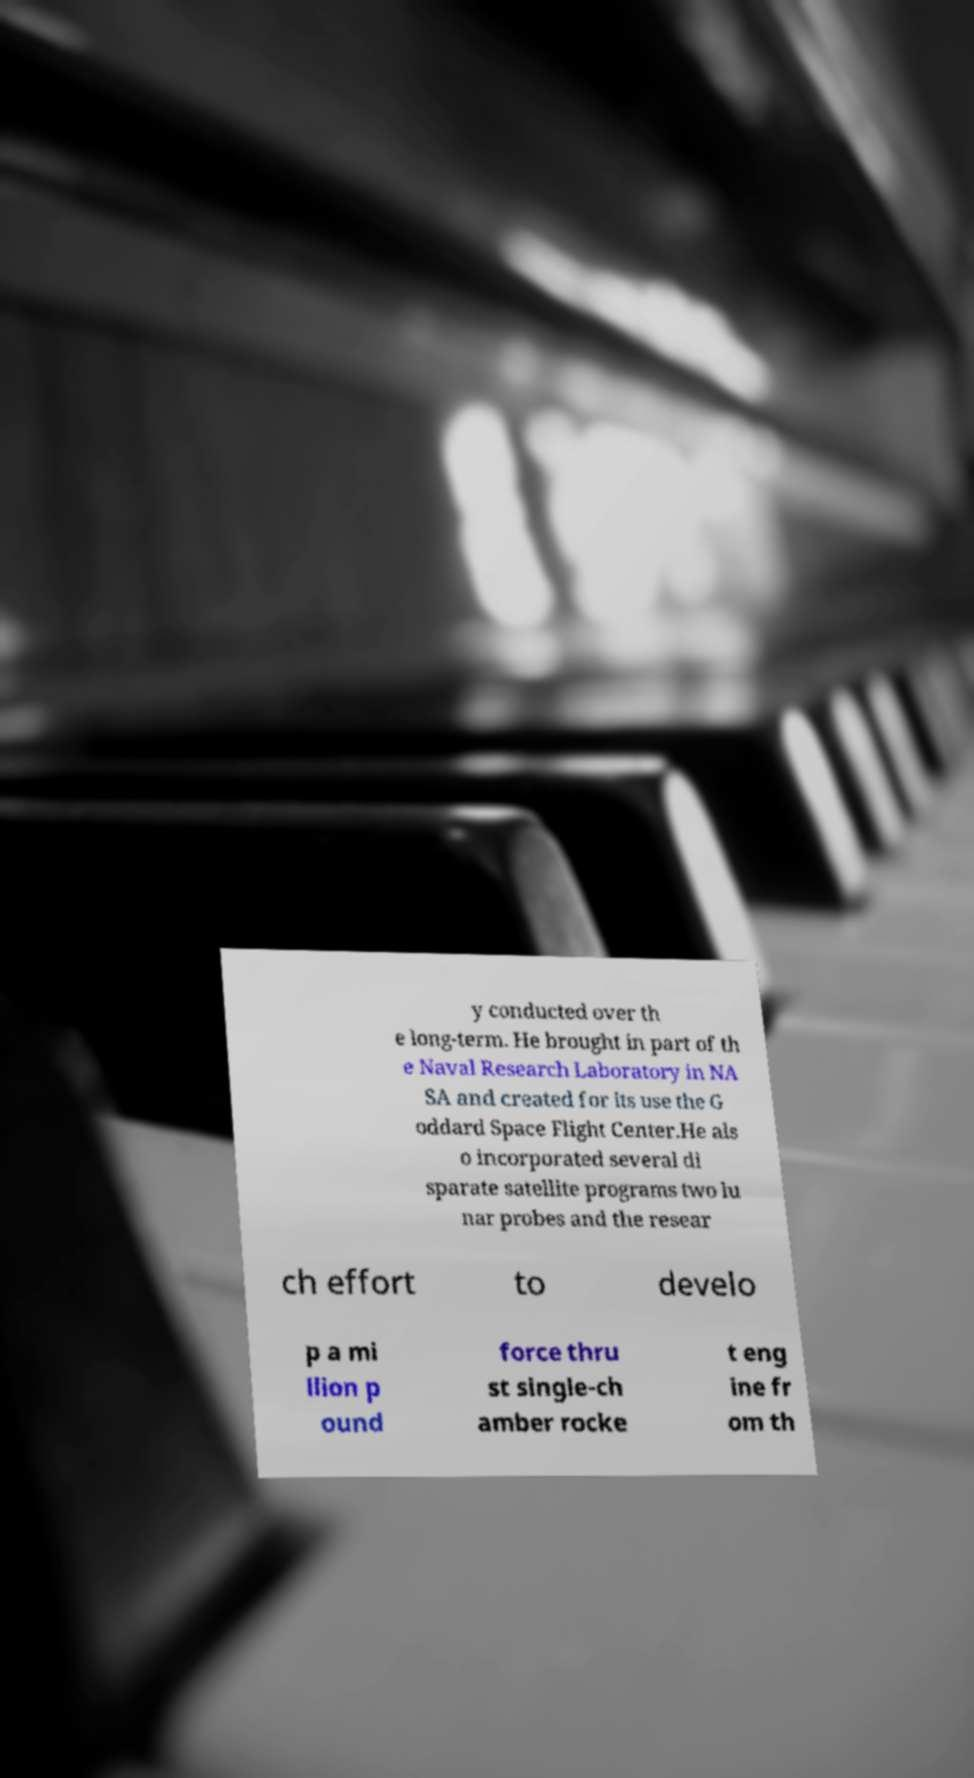For documentation purposes, I need the text within this image transcribed. Could you provide that? y conducted over th e long-term. He brought in part of th e Naval Research Laboratory in NA SA and created for its use the G oddard Space Flight Center.He als o incorporated several di sparate satellite programs two lu nar probes and the resear ch effort to develo p a mi llion p ound force thru st single-ch amber rocke t eng ine fr om th 